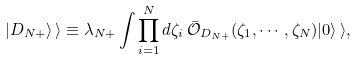Convert formula to latex. <formula><loc_0><loc_0><loc_500><loc_500>| D _ { N + } \rangle \, \rangle \equiv \lambda _ { N + } \int \prod _ { i = 1 } ^ { N } d \zeta _ { i } \, \bar { \mathcal { O } } _ { D _ { N + } } ( \zeta _ { 1 } , \cdots , \zeta _ { N } ) | 0 \rangle \, \rangle ,</formula> 